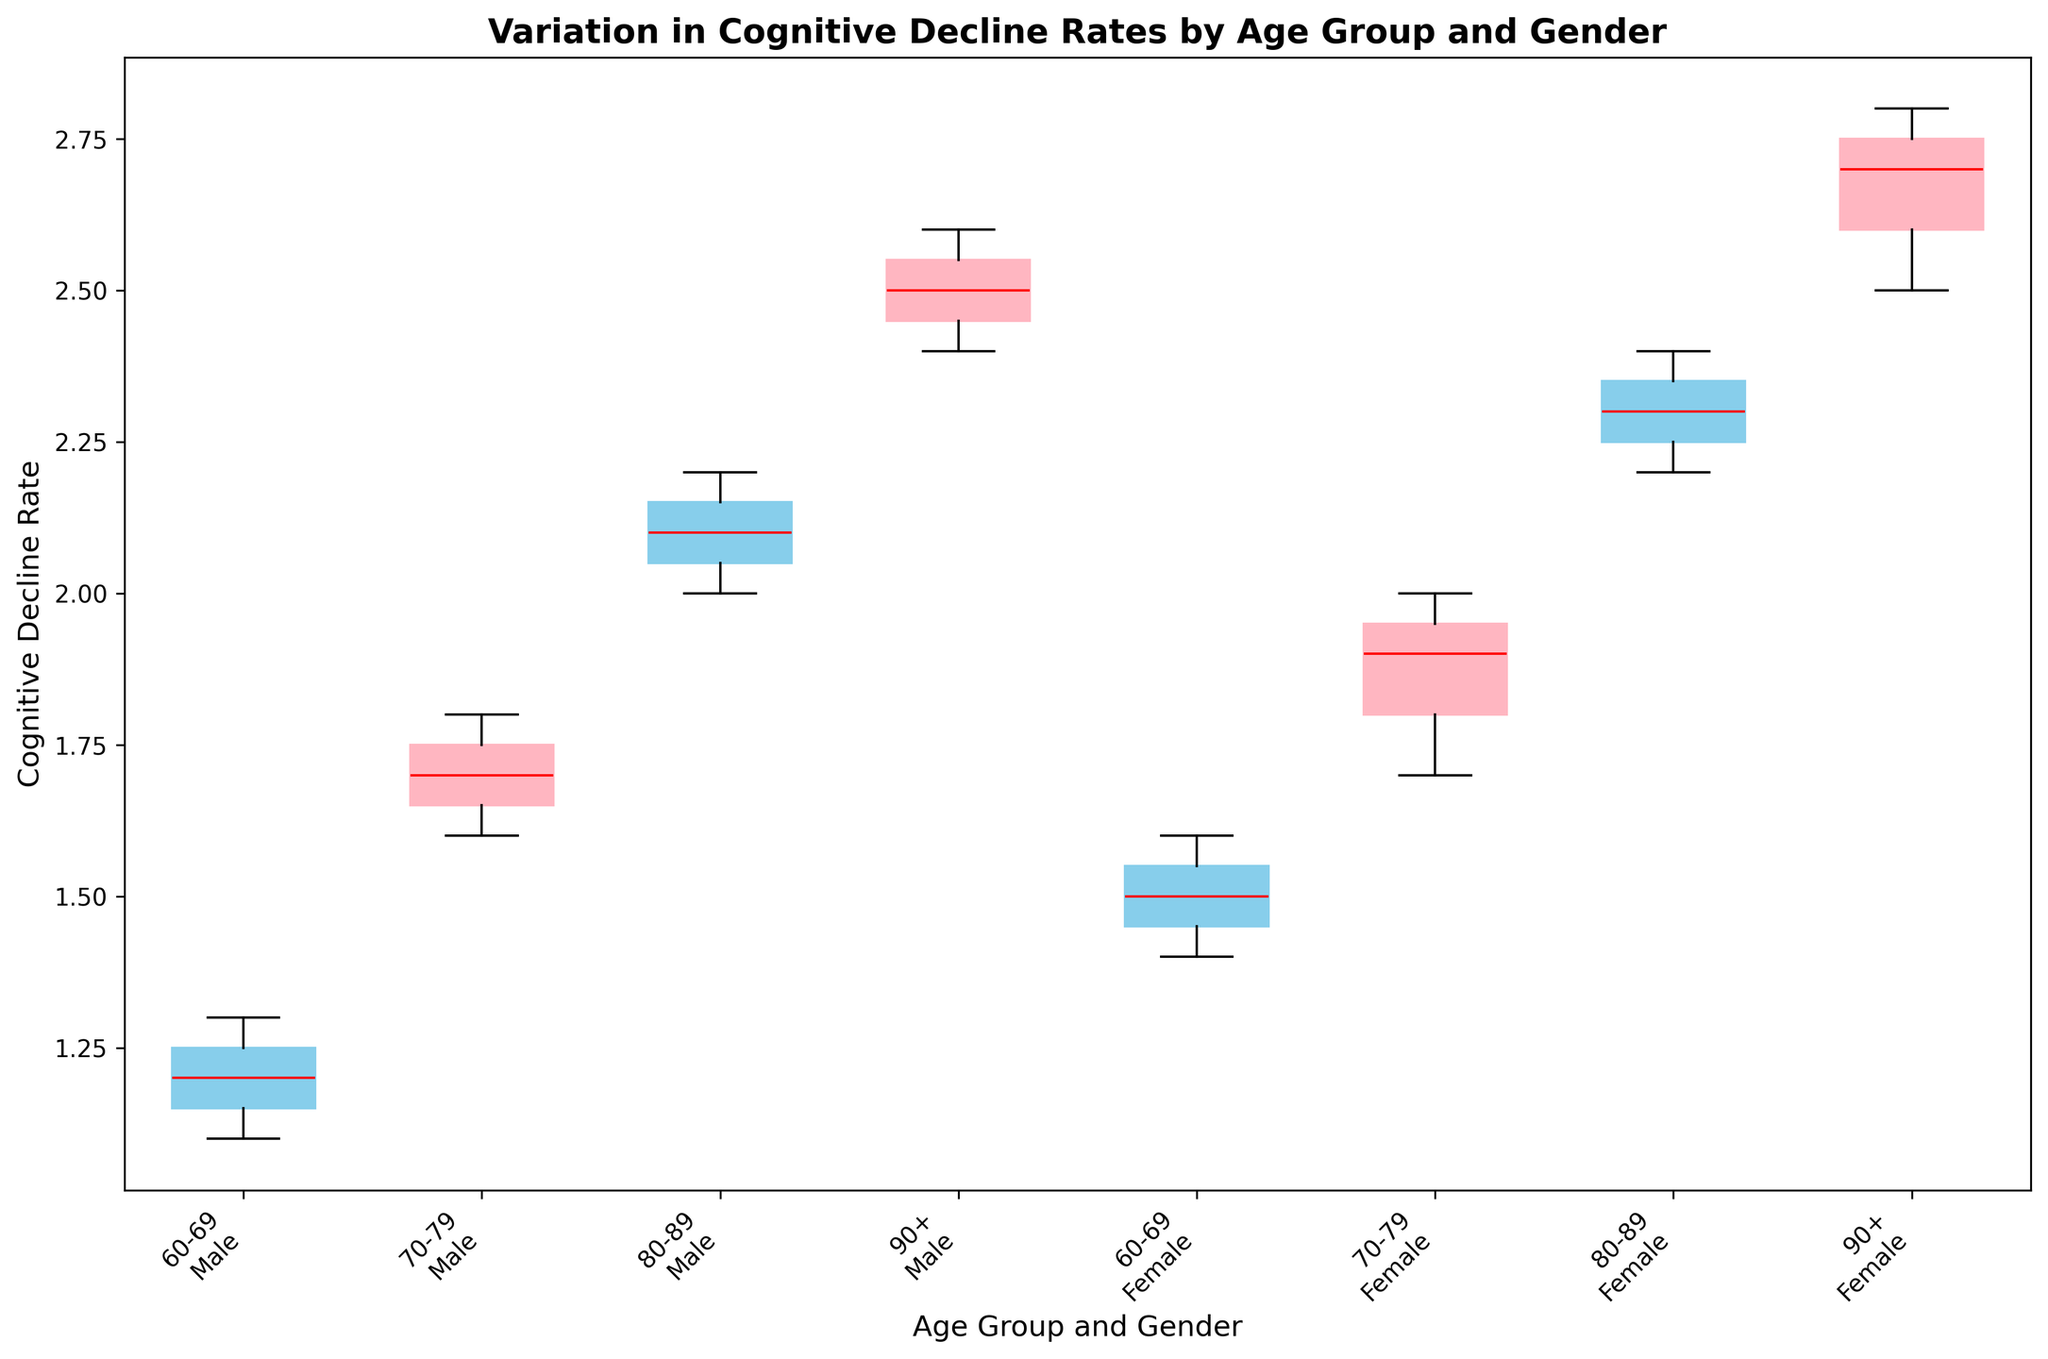What's the median cognitive decline rate for females aged 70-79? The figure has a box plot that shows the median as a red line within each box. For females aged 70-79, locate the box labeled '70-79 Female' and identify the red median line.
Answer: 1.9 Which age group and gender combination has the highest median cognitive decline rate? Look at the red median lines within each box in the box plot and identify the one with the highest value. The box labeled '90+ Female' shows the highest median.
Answer: 90+ Female Is the cognitive decline rate higher for males or females in the 80-89 age group? Compare the boxes labeled '80-89 Male' and '80-89 Female'. The red median line for '80-89 Female' is higher than that for '80-89 Male'.
Answer: Females Which age group has the most significant difference in median cognitive decline rates between males and females? Calculate the difference between the medians of males and females in each age group. From visual inspection, the 80-89 age group shows the most significant difference.
Answer: 80-89 What's the general trend in cognitive decline rates as age increases, for both genders? Examine the box plots from youngest to oldest age groups for both genders and observe the median lines (red). They generally trend upwards, indicating higher cognitive decline rates as age increases.
Answer: Increasing Among males, which age group shows the least variation in cognitive decline rates? The least variation is indicated by the narrowest box (i.e., shortest distance between upper and lower quartiles). For males, the '60-69 Male' box appears to be narrowest.
Answer: 60-69 Which gender shows higher cognitive decline rates at every age group? Compare male and female boxes within each age group. Females consistently show higher median cognitive decline rates in all age groups.
Answer: Females What is the median cognitive decline rate for the 90+ Male group, and how does it compare to the 90+ Female group's median rate? Locate the red median lines for both '90+ Male' and '90+ Female'. The median for '90+ Male' is 2.5 and for '90+ Female' is 2.7. Comparison shows the female median is higher.
Answer: 2.5, 2.7; Female is higher Is the interquartile range larger for males or females in the age group 70-79? The interquartile range (IQR) is the height of the box. Comparing the boxes for '70-79 Male' and '70-79 Female', the female box is taller, indicating a larger IQR.
Answer: Females What is the cognitive decline rate range for females aged 80-89? The range is the difference between the maximum and minimum values shown by the whiskers on the '80-89 Female' box plot. The whiskers extend from 2.2 to 2.4.
Answer: 2.2 to 2.4 